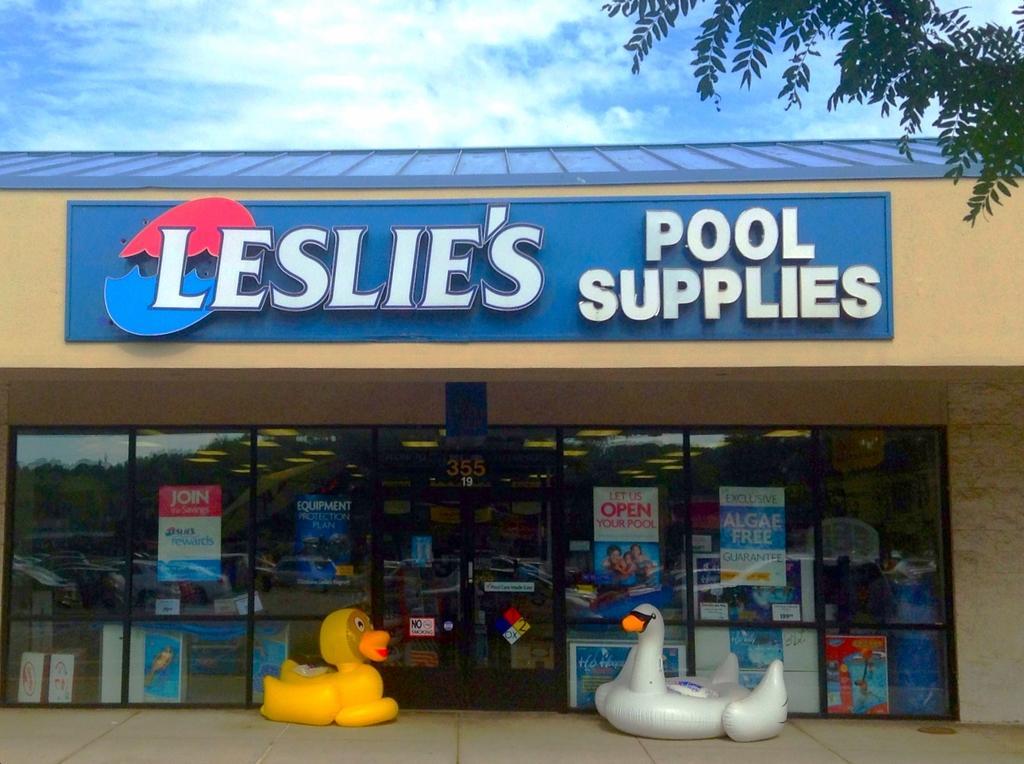Can you describe this image briefly? In this image, we can see a store and there is some text on the board and we can see posts, toys and there are glass doors and there is a tree. At the top, there are clouds in the sky and at the bottom, there is a road. 